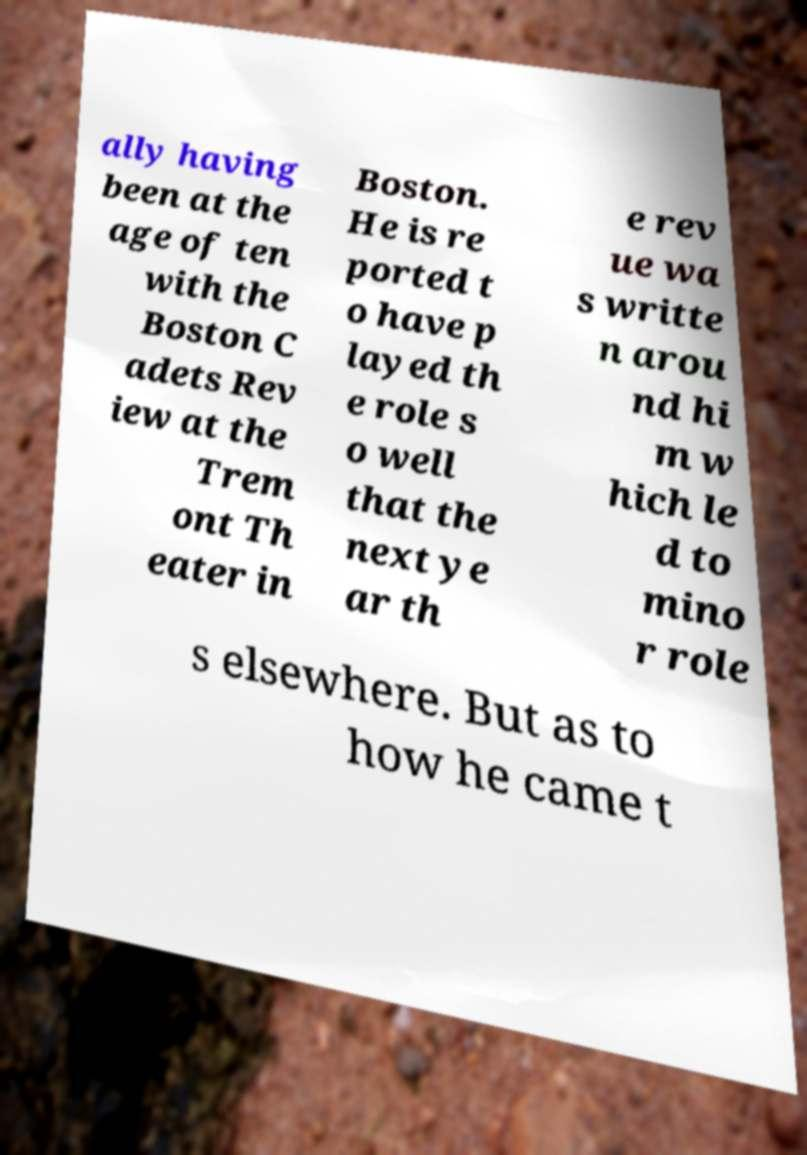Can you accurately transcribe the text from the provided image for me? ally having been at the age of ten with the Boston C adets Rev iew at the Trem ont Th eater in Boston. He is re ported t o have p layed th e role s o well that the next ye ar th e rev ue wa s writte n arou nd hi m w hich le d to mino r role s elsewhere. But as to how he came t 